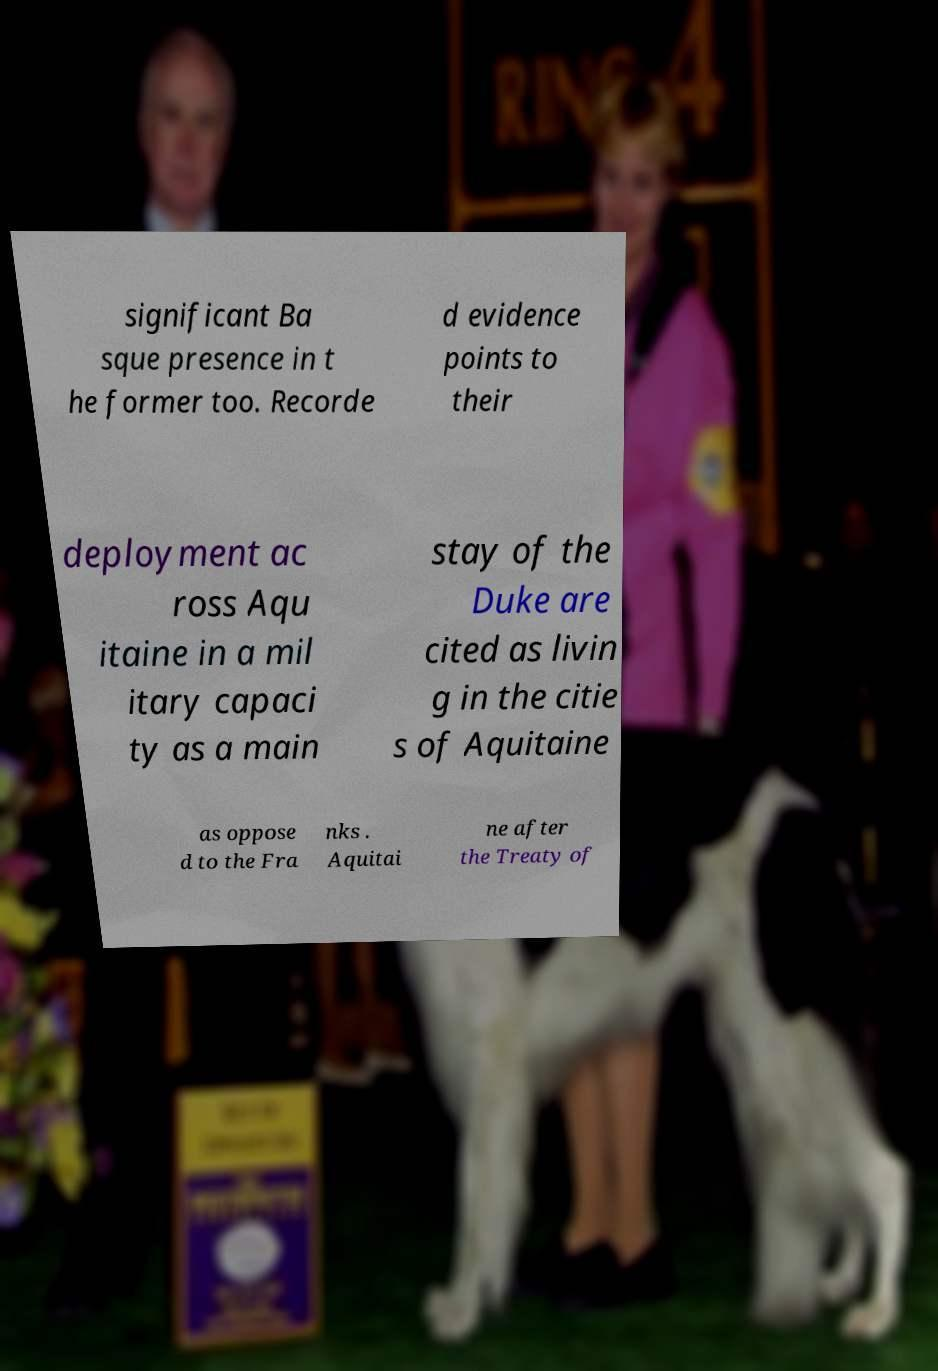There's text embedded in this image that I need extracted. Can you transcribe it verbatim? significant Ba sque presence in t he former too. Recorde d evidence points to their deployment ac ross Aqu itaine in a mil itary capaci ty as a main stay of the Duke are cited as livin g in the citie s of Aquitaine as oppose d to the Fra nks . Aquitai ne after the Treaty of 